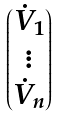<formula> <loc_0><loc_0><loc_500><loc_500>\begin{pmatrix} \dot { V } _ { 1 } \\ \vdots \\ \dot { V } _ { n } \end{pmatrix}</formula> 